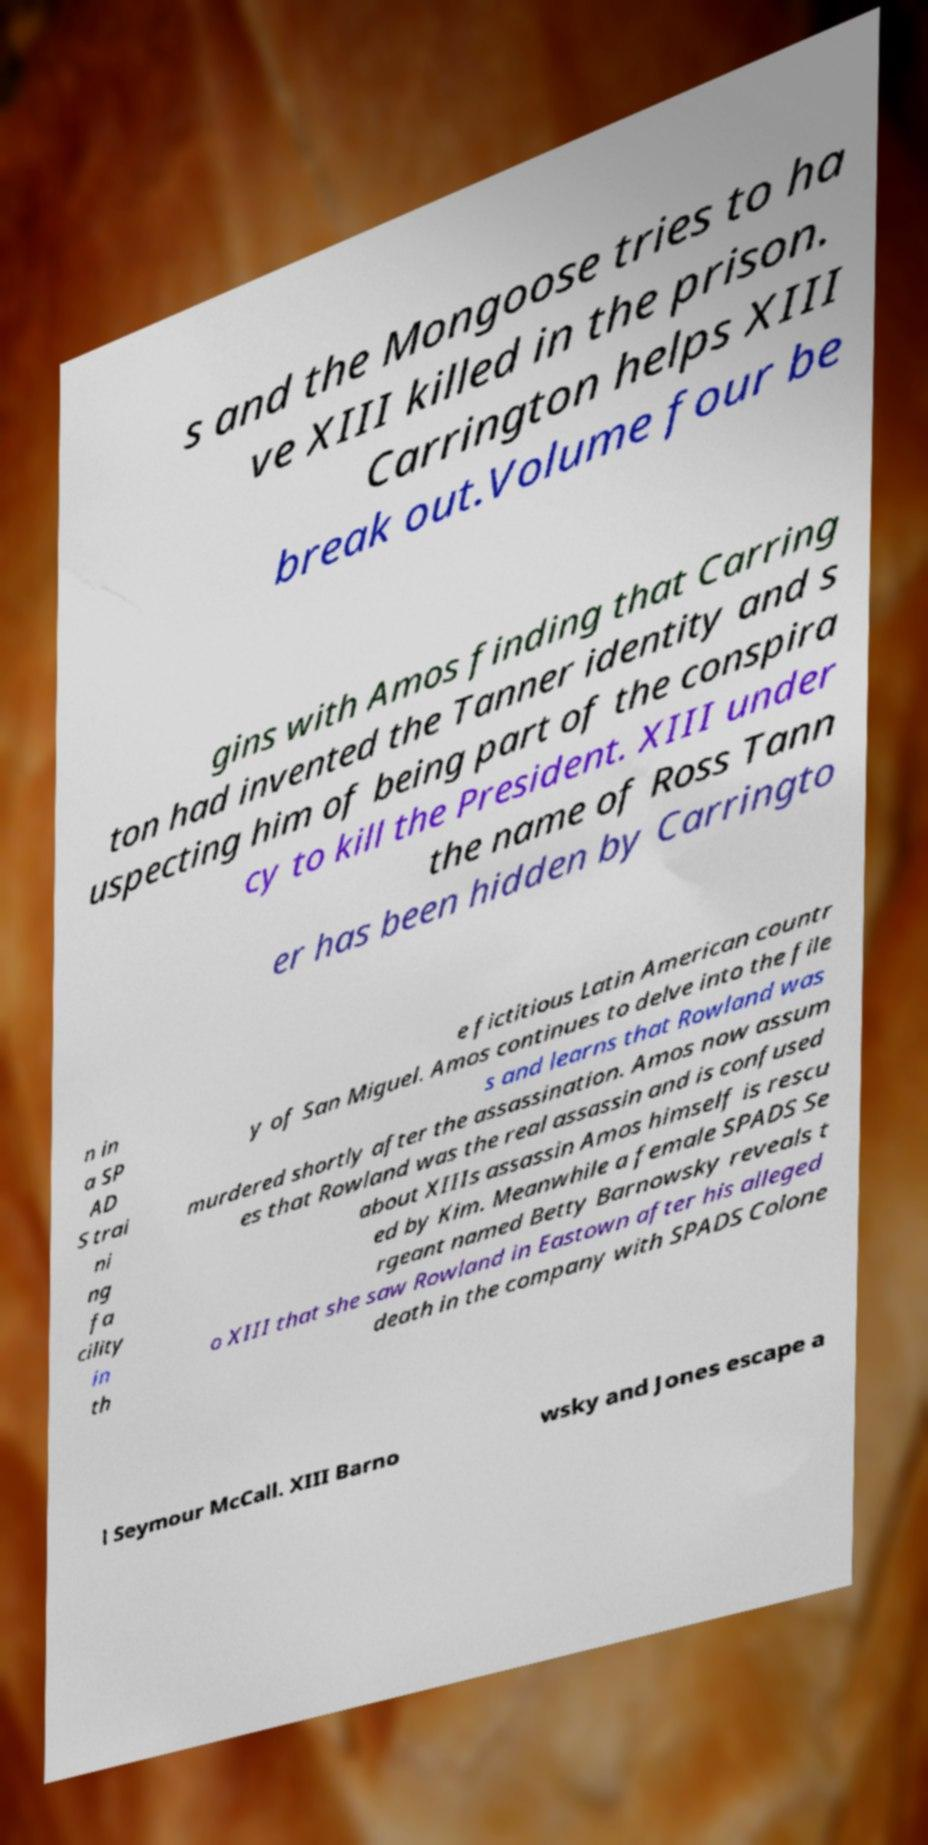For documentation purposes, I need the text within this image transcribed. Could you provide that? s and the Mongoose tries to ha ve XIII killed in the prison. Carrington helps XIII break out.Volume four be gins with Amos finding that Carring ton had invented the Tanner identity and s uspecting him of being part of the conspira cy to kill the President. XIII under the name of Ross Tann er has been hidden by Carringto n in a SP AD S trai ni ng fa cility in th e fictitious Latin American countr y of San Miguel. Amos continues to delve into the file s and learns that Rowland was murdered shortly after the assassination. Amos now assum es that Rowland was the real assassin and is confused about XIIIs assassin Amos himself is rescu ed by Kim. Meanwhile a female SPADS Se rgeant named Betty Barnowsky reveals t o XIII that she saw Rowland in Eastown after his alleged death in the company with SPADS Colone l Seymour McCall. XIII Barno wsky and Jones escape a 